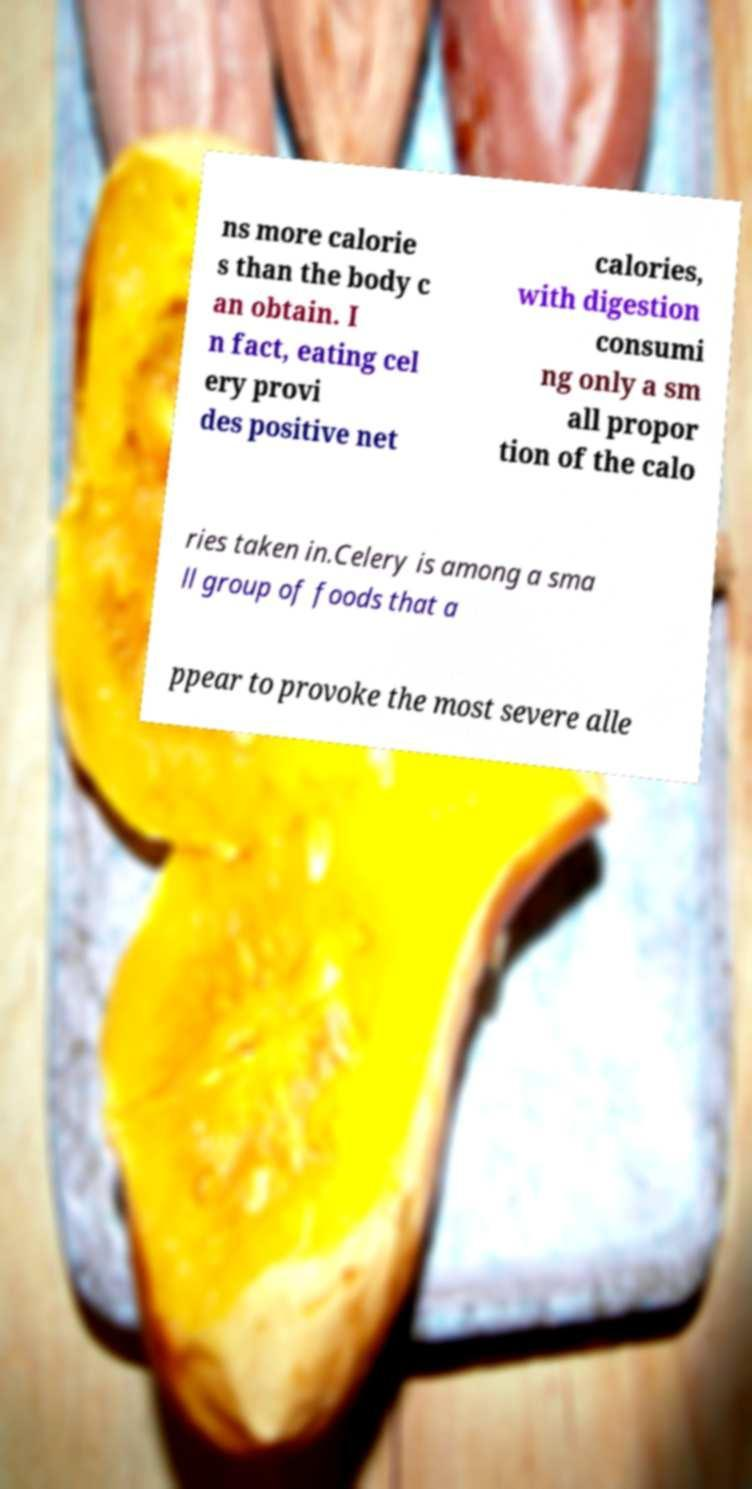Can you read and provide the text displayed in the image?This photo seems to have some interesting text. Can you extract and type it out for me? ns more calorie s than the body c an obtain. I n fact, eating cel ery provi des positive net calories, with digestion consumi ng only a sm all propor tion of the calo ries taken in.Celery is among a sma ll group of foods that a ppear to provoke the most severe alle 